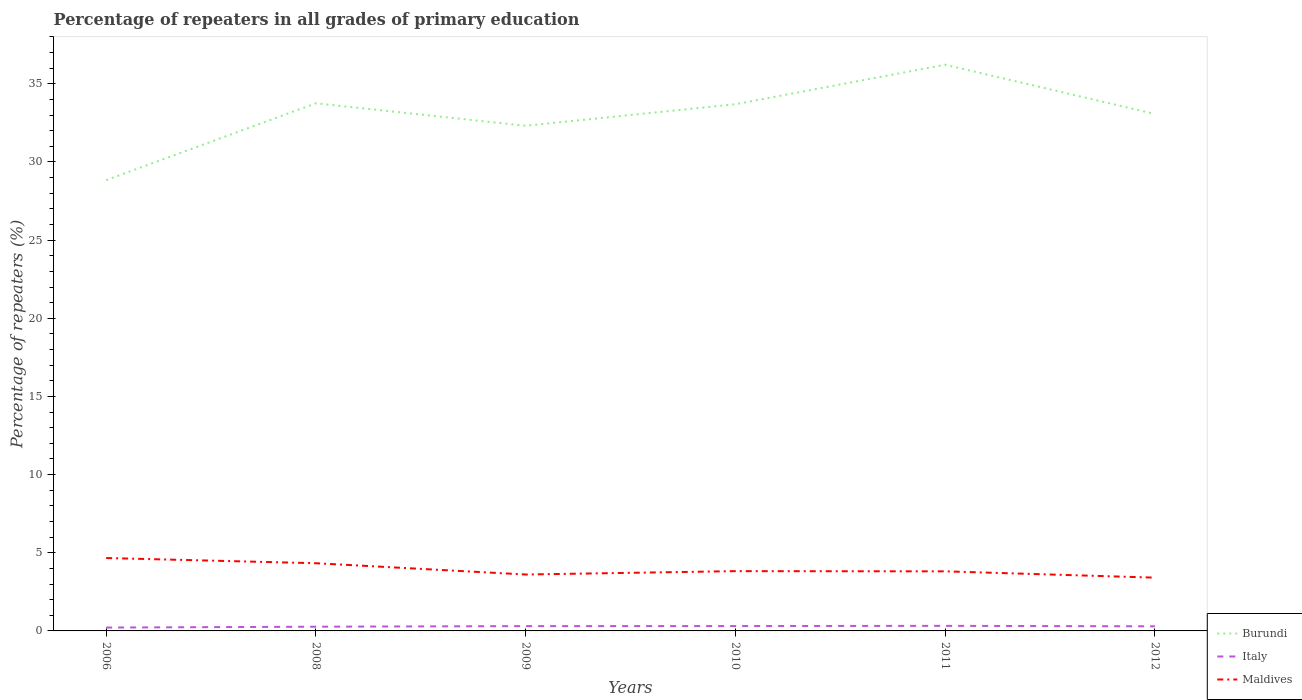How many different coloured lines are there?
Offer a very short reply. 3. Does the line corresponding to Burundi intersect with the line corresponding to Maldives?
Give a very brief answer. No. Across all years, what is the maximum percentage of repeaters in Burundi?
Your response must be concise. 28.84. What is the total percentage of repeaters in Italy in the graph?
Your answer should be very brief. -0.01. What is the difference between the highest and the second highest percentage of repeaters in Burundi?
Offer a terse response. 7.38. What is the difference between the highest and the lowest percentage of repeaters in Italy?
Provide a succinct answer. 4. How many lines are there?
Offer a terse response. 3. How many years are there in the graph?
Offer a terse response. 6. Are the values on the major ticks of Y-axis written in scientific E-notation?
Your answer should be compact. No. Does the graph contain any zero values?
Give a very brief answer. No. Where does the legend appear in the graph?
Ensure brevity in your answer.  Bottom right. How many legend labels are there?
Give a very brief answer. 3. What is the title of the graph?
Give a very brief answer. Percentage of repeaters in all grades of primary education. Does "Honduras" appear as one of the legend labels in the graph?
Your answer should be very brief. No. What is the label or title of the Y-axis?
Offer a terse response. Percentage of repeaters (%). What is the Percentage of repeaters (%) of Burundi in 2006?
Ensure brevity in your answer.  28.84. What is the Percentage of repeaters (%) in Italy in 2006?
Provide a succinct answer. 0.21. What is the Percentage of repeaters (%) in Maldives in 2006?
Provide a short and direct response. 4.66. What is the Percentage of repeaters (%) of Burundi in 2008?
Your answer should be compact. 33.75. What is the Percentage of repeaters (%) of Italy in 2008?
Offer a very short reply. 0.27. What is the Percentage of repeaters (%) in Maldives in 2008?
Provide a succinct answer. 4.33. What is the Percentage of repeaters (%) of Burundi in 2009?
Your answer should be compact. 32.31. What is the Percentage of repeaters (%) of Italy in 2009?
Offer a very short reply. 0.31. What is the Percentage of repeaters (%) in Maldives in 2009?
Keep it short and to the point. 3.61. What is the Percentage of repeaters (%) in Burundi in 2010?
Keep it short and to the point. 33.69. What is the Percentage of repeaters (%) of Italy in 2010?
Make the answer very short. 0.31. What is the Percentage of repeaters (%) of Maldives in 2010?
Your response must be concise. 3.82. What is the Percentage of repeaters (%) in Burundi in 2011?
Your answer should be compact. 36.22. What is the Percentage of repeaters (%) of Italy in 2011?
Your answer should be compact. 0.32. What is the Percentage of repeaters (%) of Maldives in 2011?
Ensure brevity in your answer.  3.81. What is the Percentage of repeaters (%) of Burundi in 2012?
Your answer should be compact. 33.07. What is the Percentage of repeaters (%) in Italy in 2012?
Your answer should be very brief. 0.29. What is the Percentage of repeaters (%) of Maldives in 2012?
Provide a short and direct response. 3.41. Across all years, what is the maximum Percentage of repeaters (%) of Burundi?
Your answer should be very brief. 36.22. Across all years, what is the maximum Percentage of repeaters (%) of Italy?
Your response must be concise. 0.32. Across all years, what is the maximum Percentage of repeaters (%) in Maldives?
Make the answer very short. 4.66. Across all years, what is the minimum Percentage of repeaters (%) of Burundi?
Offer a very short reply. 28.84. Across all years, what is the minimum Percentage of repeaters (%) of Italy?
Offer a very short reply. 0.21. Across all years, what is the minimum Percentage of repeaters (%) in Maldives?
Your answer should be compact. 3.41. What is the total Percentage of repeaters (%) in Burundi in the graph?
Offer a terse response. 197.88. What is the total Percentage of repeaters (%) of Italy in the graph?
Your answer should be very brief. 1.72. What is the total Percentage of repeaters (%) of Maldives in the graph?
Keep it short and to the point. 23.65. What is the difference between the Percentage of repeaters (%) of Burundi in 2006 and that in 2008?
Your answer should be very brief. -4.92. What is the difference between the Percentage of repeaters (%) of Italy in 2006 and that in 2008?
Make the answer very short. -0.05. What is the difference between the Percentage of repeaters (%) of Maldives in 2006 and that in 2008?
Keep it short and to the point. 0.33. What is the difference between the Percentage of repeaters (%) of Burundi in 2006 and that in 2009?
Provide a short and direct response. -3.48. What is the difference between the Percentage of repeaters (%) of Italy in 2006 and that in 2009?
Give a very brief answer. -0.09. What is the difference between the Percentage of repeaters (%) in Maldives in 2006 and that in 2009?
Give a very brief answer. 1.05. What is the difference between the Percentage of repeaters (%) in Burundi in 2006 and that in 2010?
Make the answer very short. -4.86. What is the difference between the Percentage of repeaters (%) in Italy in 2006 and that in 2010?
Provide a short and direct response. -0.1. What is the difference between the Percentage of repeaters (%) in Maldives in 2006 and that in 2010?
Ensure brevity in your answer.  0.84. What is the difference between the Percentage of repeaters (%) of Burundi in 2006 and that in 2011?
Give a very brief answer. -7.38. What is the difference between the Percentage of repeaters (%) of Italy in 2006 and that in 2011?
Provide a succinct answer. -0.11. What is the difference between the Percentage of repeaters (%) of Maldives in 2006 and that in 2011?
Make the answer very short. 0.85. What is the difference between the Percentage of repeaters (%) of Burundi in 2006 and that in 2012?
Your answer should be compact. -4.23. What is the difference between the Percentage of repeaters (%) of Italy in 2006 and that in 2012?
Keep it short and to the point. -0.08. What is the difference between the Percentage of repeaters (%) of Maldives in 2006 and that in 2012?
Your response must be concise. 1.26. What is the difference between the Percentage of repeaters (%) of Burundi in 2008 and that in 2009?
Keep it short and to the point. 1.44. What is the difference between the Percentage of repeaters (%) of Italy in 2008 and that in 2009?
Provide a succinct answer. -0.04. What is the difference between the Percentage of repeaters (%) in Maldives in 2008 and that in 2009?
Offer a very short reply. 0.72. What is the difference between the Percentage of repeaters (%) of Burundi in 2008 and that in 2010?
Offer a terse response. 0.06. What is the difference between the Percentage of repeaters (%) in Italy in 2008 and that in 2010?
Your answer should be compact. -0.04. What is the difference between the Percentage of repeaters (%) in Maldives in 2008 and that in 2010?
Offer a very short reply. 0.51. What is the difference between the Percentage of repeaters (%) of Burundi in 2008 and that in 2011?
Offer a very short reply. -2.47. What is the difference between the Percentage of repeaters (%) of Italy in 2008 and that in 2011?
Provide a succinct answer. -0.05. What is the difference between the Percentage of repeaters (%) in Maldives in 2008 and that in 2011?
Provide a succinct answer. 0.52. What is the difference between the Percentage of repeaters (%) of Burundi in 2008 and that in 2012?
Your answer should be very brief. 0.68. What is the difference between the Percentage of repeaters (%) of Italy in 2008 and that in 2012?
Offer a terse response. -0.02. What is the difference between the Percentage of repeaters (%) in Maldives in 2008 and that in 2012?
Offer a very short reply. 0.92. What is the difference between the Percentage of repeaters (%) of Burundi in 2009 and that in 2010?
Give a very brief answer. -1.38. What is the difference between the Percentage of repeaters (%) in Italy in 2009 and that in 2010?
Your response must be concise. -0. What is the difference between the Percentage of repeaters (%) of Maldives in 2009 and that in 2010?
Offer a terse response. -0.22. What is the difference between the Percentage of repeaters (%) of Burundi in 2009 and that in 2011?
Provide a succinct answer. -3.91. What is the difference between the Percentage of repeaters (%) in Italy in 2009 and that in 2011?
Keep it short and to the point. -0.02. What is the difference between the Percentage of repeaters (%) of Maldives in 2009 and that in 2011?
Offer a terse response. -0.2. What is the difference between the Percentage of repeaters (%) in Burundi in 2009 and that in 2012?
Keep it short and to the point. -0.76. What is the difference between the Percentage of repeaters (%) in Italy in 2009 and that in 2012?
Give a very brief answer. 0.01. What is the difference between the Percentage of repeaters (%) in Maldives in 2009 and that in 2012?
Offer a very short reply. 0.2. What is the difference between the Percentage of repeaters (%) in Burundi in 2010 and that in 2011?
Your answer should be compact. -2.53. What is the difference between the Percentage of repeaters (%) in Italy in 2010 and that in 2011?
Your answer should be compact. -0.01. What is the difference between the Percentage of repeaters (%) of Maldives in 2010 and that in 2011?
Your response must be concise. 0.01. What is the difference between the Percentage of repeaters (%) of Burundi in 2010 and that in 2012?
Make the answer very short. 0.62. What is the difference between the Percentage of repeaters (%) of Italy in 2010 and that in 2012?
Make the answer very short. 0.02. What is the difference between the Percentage of repeaters (%) of Maldives in 2010 and that in 2012?
Ensure brevity in your answer.  0.42. What is the difference between the Percentage of repeaters (%) in Burundi in 2011 and that in 2012?
Your answer should be compact. 3.15. What is the difference between the Percentage of repeaters (%) of Italy in 2011 and that in 2012?
Provide a succinct answer. 0.03. What is the difference between the Percentage of repeaters (%) in Maldives in 2011 and that in 2012?
Provide a short and direct response. 0.4. What is the difference between the Percentage of repeaters (%) in Burundi in 2006 and the Percentage of repeaters (%) in Italy in 2008?
Provide a succinct answer. 28.57. What is the difference between the Percentage of repeaters (%) in Burundi in 2006 and the Percentage of repeaters (%) in Maldives in 2008?
Ensure brevity in your answer.  24.5. What is the difference between the Percentage of repeaters (%) of Italy in 2006 and the Percentage of repeaters (%) of Maldives in 2008?
Give a very brief answer. -4.12. What is the difference between the Percentage of repeaters (%) in Burundi in 2006 and the Percentage of repeaters (%) in Italy in 2009?
Ensure brevity in your answer.  28.53. What is the difference between the Percentage of repeaters (%) of Burundi in 2006 and the Percentage of repeaters (%) of Maldives in 2009?
Provide a short and direct response. 25.23. What is the difference between the Percentage of repeaters (%) in Italy in 2006 and the Percentage of repeaters (%) in Maldives in 2009?
Make the answer very short. -3.39. What is the difference between the Percentage of repeaters (%) of Burundi in 2006 and the Percentage of repeaters (%) of Italy in 2010?
Your response must be concise. 28.52. What is the difference between the Percentage of repeaters (%) of Burundi in 2006 and the Percentage of repeaters (%) of Maldives in 2010?
Make the answer very short. 25.01. What is the difference between the Percentage of repeaters (%) in Italy in 2006 and the Percentage of repeaters (%) in Maldives in 2010?
Your response must be concise. -3.61. What is the difference between the Percentage of repeaters (%) in Burundi in 2006 and the Percentage of repeaters (%) in Italy in 2011?
Offer a very short reply. 28.51. What is the difference between the Percentage of repeaters (%) in Burundi in 2006 and the Percentage of repeaters (%) in Maldives in 2011?
Offer a terse response. 25.02. What is the difference between the Percentage of repeaters (%) in Italy in 2006 and the Percentage of repeaters (%) in Maldives in 2011?
Ensure brevity in your answer.  -3.6. What is the difference between the Percentage of repeaters (%) of Burundi in 2006 and the Percentage of repeaters (%) of Italy in 2012?
Provide a short and direct response. 28.54. What is the difference between the Percentage of repeaters (%) in Burundi in 2006 and the Percentage of repeaters (%) in Maldives in 2012?
Offer a terse response. 25.43. What is the difference between the Percentage of repeaters (%) in Italy in 2006 and the Percentage of repeaters (%) in Maldives in 2012?
Provide a succinct answer. -3.19. What is the difference between the Percentage of repeaters (%) of Burundi in 2008 and the Percentage of repeaters (%) of Italy in 2009?
Keep it short and to the point. 33.45. What is the difference between the Percentage of repeaters (%) of Burundi in 2008 and the Percentage of repeaters (%) of Maldives in 2009?
Give a very brief answer. 30.15. What is the difference between the Percentage of repeaters (%) of Italy in 2008 and the Percentage of repeaters (%) of Maldives in 2009?
Provide a short and direct response. -3.34. What is the difference between the Percentage of repeaters (%) in Burundi in 2008 and the Percentage of repeaters (%) in Italy in 2010?
Ensure brevity in your answer.  33.44. What is the difference between the Percentage of repeaters (%) in Burundi in 2008 and the Percentage of repeaters (%) in Maldives in 2010?
Your answer should be compact. 29.93. What is the difference between the Percentage of repeaters (%) of Italy in 2008 and the Percentage of repeaters (%) of Maldives in 2010?
Your response must be concise. -3.56. What is the difference between the Percentage of repeaters (%) in Burundi in 2008 and the Percentage of repeaters (%) in Italy in 2011?
Offer a very short reply. 33.43. What is the difference between the Percentage of repeaters (%) of Burundi in 2008 and the Percentage of repeaters (%) of Maldives in 2011?
Your answer should be compact. 29.94. What is the difference between the Percentage of repeaters (%) of Italy in 2008 and the Percentage of repeaters (%) of Maldives in 2011?
Give a very brief answer. -3.54. What is the difference between the Percentage of repeaters (%) of Burundi in 2008 and the Percentage of repeaters (%) of Italy in 2012?
Your answer should be compact. 33.46. What is the difference between the Percentage of repeaters (%) in Burundi in 2008 and the Percentage of repeaters (%) in Maldives in 2012?
Your answer should be compact. 30.35. What is the difference between the Percentage of repeaters (%) of Italy in 2008 and the Percentage of repeaters (%) of Maldives in 2012?
Your response must be concise. -3.14. What is the difference between the Percentage of repeaters (%) in Burundi in 2009 and the Percentage of repeaters (%) in Italy in 2010?
Ensure brevity in your answer.  32. What is the difference between the Percentage of repeaters (%) in Burundi in 2009 and the Percentage of repeaters (%) in Maldives in 2010?
Your answer should be very brief. 28.49. What is the difference between the Percentage of repeaters (%) of Italy in 2009 and the Percentage of repeaters (%) of Maldives in 2010?
Offer a terse response. -3.52. What is the difference between the Percentage of repeaters (%) in Burundi in 2009 and the Percentage of repeaters (%) in Italy in 2011?
Make the answer very short. 31.99. What is the difference between the Percentage of repeaters (%) in Burundi in 2009 and the Percentage of repeaters (%) in Maldives in 2011?
Ensure brevity in your answer.  28.5. What is the difference between the Percentage of repeaters (%) of Italy in 2009 and the Percentage of repeaters (%) of Maldives in 2011?
Keep it short and to the point. -3.5. What is the difference between the Percentage of repeaters (%) in Burundi in 2009 and the Percentage of repeaters (%) in Italy in 2012?
Make the answer very short. 32.02. What is the difference between the Percentage of repeaters (%) of Burundi in 2009 and the Percentage of repeaters (%) of Maldives in 2012?
Offer a terse response. 28.91. What is the difference between the Percentage of repeaters (%) in Italy in 2009 and the Percentage of repeaters (%) in Maldives in 2012?
Provide a short and direct response. -3.1. What is the difference between the Percentage of repeaters (%) of Burundi in 2010 and the Percentage of repeaters (%) of Italy in 2011?
Provide a short and direct response. 33.37. What is the difference between the Percentage of repeaters (%) of Burundi in 2010 and the Percentage of repeaters (%) of Maldives in 2011?
Offer a very short reply. 29.88. What is the difference between the Percentage of repeaters (%) of Italy in 2010 and the Percentage of repeaters (%) of Maldives in 2011?
Make the answer very short. -3.5. What is the difference between the Percentage of repeaters (%) in Burundi in 2010 and the Percentage of repeaters (%) in Italy in 2012?
Your answer should be very brief. 33.4. What is the difference between the Percentage of repeaters (%) in Burundi in 2010 and the Percentage of repeaters (%) in Maldives in 2012?
Your response must be concise. 30.29. What is the difference between the Percentage of repeaters (%) in Italy in 2010 and the Percentage of repeaters (%) in Maldives in 2012?
Your response must be concise. -3.1. What is the difference between the Percentage of repeaters (%) in Burundi in 2011 and the Percentage of repeaters (%) in Italy in 2012?
Your response must be concise. 35.93. What is the difference between the Percentage of repeaters (%) in Burundi in 2011 and the Percentage of repeaters (%) in Maldives in 2012?
Provide a succinct answer. 32.81. What is the difference between the Percentage of repeaters (%) in Italy in 2011 and the Percentage of repeaters (%) in Maldives in 2012?
Your answer should be compact. -3.08. What is the average Percentage of repeaters (%) in Burundi per year?
Your answer should be very brief. 32.98. What is the average Percentage of repeaters (%) of Italy per year?
Your answer should be compact. 0.29. What is the average Percentage of repeaters (%) of Maldives per year?
Provide a short and direct response. 3.94. In the year 2006, what is the difference between the Percentage of repeaters (%) in Burundi and Percentage of repeaters (%) in Italy?
Offer a very short reply. 28.62. In the year 2006, what is the difference between the Percentage of repeaters (%) of Burundi and Percentage of repeaters (%) of Maldives?
Provide a succinct answer. 24.17. In the year 2006, what is the difference between the Percentage of repeaters (%) in Italy and Percentage of repeaters (%) in Maldives?
Keep it short and to the point. -4.45. In the year 2008, what is the difference between the Percentage of repeaters (%) of Burundi and Percentage of repeaters (%) of Italy?
Your response must be concise. 33.48. In the year 2008, what is the difference between the Percentage of repeaters (%) in Burundi and Percentage of repeaters (%) in Maldives?
Give a very brief answer. 29.42. In the year 2008, what is the difference between the Percentage of repeaters (%) in Italy and Percentage of repeaters (%) in Maldives?
Your response must be concise. -4.06. In the year 2009, what is the difference between the Percentage of repeaters (%) in Burundi and Percentage of repeaters (%) in Italy?
Offer a very short reply. 32.01. In the year 2009, what is the difference between the Percentage of repeaters (%) in Burundi and Percentage of repeaters (%) in Maldives?
Ensure brevity in your answer.  28.7. In the year 2009, what is the difference between the Percentage of repeaters (%) in Italy and Percentage of repeaters (%) in Maldives?
Ensure brevity in your answer.  -3.3. In the year 2010, what is the difference between the Percentage of repeaters (%) of Burundi and Percentage of repeaters (%) of Italy?
Your answer should be compact. 33.38. In the year 2010, what is the difference between the Percentage of repeaters (%) of Burundi and Percentage of repeaters (%) of Maldives?
Give a very brief answer. 29.87. In the year 2010, what is the difference between the Percentage of repeaters (%) of Italy and Percentage of repeaters (%) of Maldives?
Offer a terse response. -3.51. In the year 2011, what is the difference between the Percentage of repeaters (%) in Burundi and Percentage of repeaters (%) in Italy?
Offer a terse response. 35.9. In the year 2011, what is the difference between the Percentage of repeaters (%) in Burundi and Percentage of repeaters (%) in Maldives?
Your response must be concise. 32.41. In the year 2011, what is the difference between the Percentage of repeaters (%) in Italy and Percentage of repeaters (%) in Maldives?
Your answer should be very brief. -3.49. In the year 2012, what is the difference between the Percentage of repeaters (%) in Burundi and Percentage of repeaters (%) in Italy?
Offer a terse response. 32.77. In the year 2012, what is the difference between the Percentage of repeaters (%) in Burundi and Percentage of repeaters (%) in Maldives?
Offer a very short reply. 29.66. In the year 2012, what is the difference between the Percentage of repeaters (%) in Italy and Percentage of repeaters (%) in Maldives?
Your answer should be compact. -3.11. What is the ratio of the Percentage of repeaters (%) in Burundi in 2006 to that in 2008?
Provide a short and direct response. 0.85. What is the ratio of the Percentage of repeaters (%) of Italy in 2006 to that in 2008?
Offer a very short reply. 0.8. What is the ratio of the Percentage of repeaters (%) of Maldives in 2006 to that in 2008?
Offer a very short reply. 1.08. What is the ratio of the Percentage of repeaters (%) of Burundi in 2006 to that in 2009?
Offer a terse response. 0.89. What is the ratio of the Percentage of repeaters (%) of Italy in 2006 to that in 2009?
Your response must be concise. 0.7. What is the ratio of the Percentage of repeaters (%) in Maldives in 2006 to that in 2009?
Ensure brevity in your answer.  1.29. What is the ratio of the Percentage of repeaters (%) in Burundi in 2006 to that in 2010?
Offer a very short reply. 0.86. What is the ratio of the Percentage of repeaters (%) of Italy in 2006 to that in 2010?
Give a very brief answer. 0.69. What is the ratio of the Percentage of repeaters (%) of Maldives in 2006 to that in 2010?
Your answer should be compact. 1.22. What is the ratio of the Percentage of repeaters (%) of Burundi in 2006 to that in 2011?
Provide a succinct answer. 0.8. What is the ratio of the Percentage of repeaters (%) of Italy in 2006 to that in 2011?
Keep it short and to the point. 0.66. What is the ratio of the Percentage of repeaters (%) of Maldives in 2006 to that in 2011?
Provide a short and direct response. 1.22. What is the ratio of the Percentage of repeaters (%) of Burundi in 2006 to that in 2012?
Provide a short and direct response. 0.87. What is the ratio of the Percentage of repeaters (%) in Italy in 2006 to that in 2012?
Provide a succinct answer. 0.73. What is the ratio of the Percentage of repeaters (%) of Maldives in 2006 to that in 2012?
Keep it short and to the point. 1.37. What is the ratio of the Percentage of repeaters (%) in Burundi in 2008 to that in 2009?
Offer a terse response. 1.04. What is the ratio of the Percentage of repeaters (%) in Italy in 2008 to that in 2009?
Offer a terse response. 0.87. What is the ratio of the Percentage of repeaters (%) in Maldives in 2008 to that in 2009?
Provide a succinct answer. 1.2. What is the ratio of the Percentage of repeaters (%) of Italy in 2008 to that in 2010?
Provide a succinct answer. 0.87. What is the ratio of the Percentage of repeaters (%) of Maldives in 2008 to that in 2010?
Keep it short and to the point. 1.13. What is the ratio of the Percentage of repeaters (%) in Burundi in 2008 to that in 2011?
Give a very brief answer. 0.93. What is the ratio of the Percentage of repeaters (%) in Italy in 2008 to that in 2011?
Your response must be concise. 0.83. What is the ratio of the Percentage of repeaters (%) in Maldives in 2008 to that in 2011?
Offer a terse response. 1.14. What is the ratio of the Percentage of repeaters (%) of Burundi in 2008 to that in 2012?
Your answer should be compact. 1.02. What is the ratio of the Percentage of repeaters (%) of Italy in 2008 to that in 2012?
Your answer should be compact. 0.92. What is the ratio of the Percentage of repeaters (%) in Maldives in 2008 to that in 2012?
Make the answer very short. 1.27. What is the ratio of the Percentage of repeaters (%) in Italy in 2009 to that in 2010?
Give a very brief answer. 0.99. What is the ratio of the Percentage of repeaters (%) of Maldives in 2009 to that in 2010?
Offer a terse response. 0.94. What is the ratio of the Percentage of repeaters (%) of Burundi in 2009 to that in 2011?
Your answer should be very brief. 0.89. What is the ratio of the Percentage of repeaters (%) of Italy in 2009 to that in 2011?
Your response must be concise. 0.95. What is the ratio of the Percentage of repeaters (%) of Maldives in 2009 to that in 2011?
Make the answer very short. 0.95. What is the ratio of the Percentage of repeaters (%) of Burundi in 2009 to that in 2012?
Give a very brief answer. 0.98. What is the ratio of the Percentage of repeaters (%) of Italy in 2009 to that in 2012?
Offer a terse response. 1.05. What is the ratio of the Percentage of repeaters (%) of Maldives in 2009 to that in 2012?
Your response must be concise. 1.06. What is the ratio of the Percentage of repeaters (%) of Burundi in 2010 to that in 2011?
Give a very brief answer. 0.93. What is the ratio of the Percentage of repeaters (%) of Italy in 2010 to that in 2011?
Give a very brief answer. 0.96. What is the ratio of the Percentage of repeaters (%) in Burundi in 2010 to that in 2012?
Provide a short and direct response. 1.02. What is the ratio of the Percentage of repeaters (%) of Italy in 2010 to that in 2012?
Provide a short and direct response. 1.06. What is the ratio of the Percentage of repeaters (%) of Maldives in 2010 to that in 2012?
Your answer should be compact. 1.12. What is the ratio of the Percentage of repeaters (%) of Burundi in 2011 to that in 2012?
Provide a short and direct response. 1.1. What is the ratio of the Percentage of repeaters (%) of Italy in 2011 to that in 2012?
Your answer should be compact. 1.1. What is the ratio of the Percentage of repeaters (%) in Maldives in 2011 to that in 2012?
Your answer should be compact. 1.12. What is the difference between the highest and the second highest Percentage of repeaters (%) in Burundi?
Provide a succinct answer. 2.47. What is the difference between the highest and the second highest Percentage of repeaters (%) of Italy?
Your response must be concise. 0.01. What is the difference between the highest and the second highest Percentage of repeaters (%) of Maldives?
Keep it short and to the point. 0.33. What is the difference between the highest and the lowest Percentage of repeaters (%) in Burundi?
Provide a succinct answer. 7.38. What is the difference between the highest and the lowest Percentage of repeaters (%) of Italy?
Provide a succinct answer. 0.11. What is the difference between the highest and the lowest Percentage of repeaters (%) of Maldives?
Your response must be concise. 1.26. 